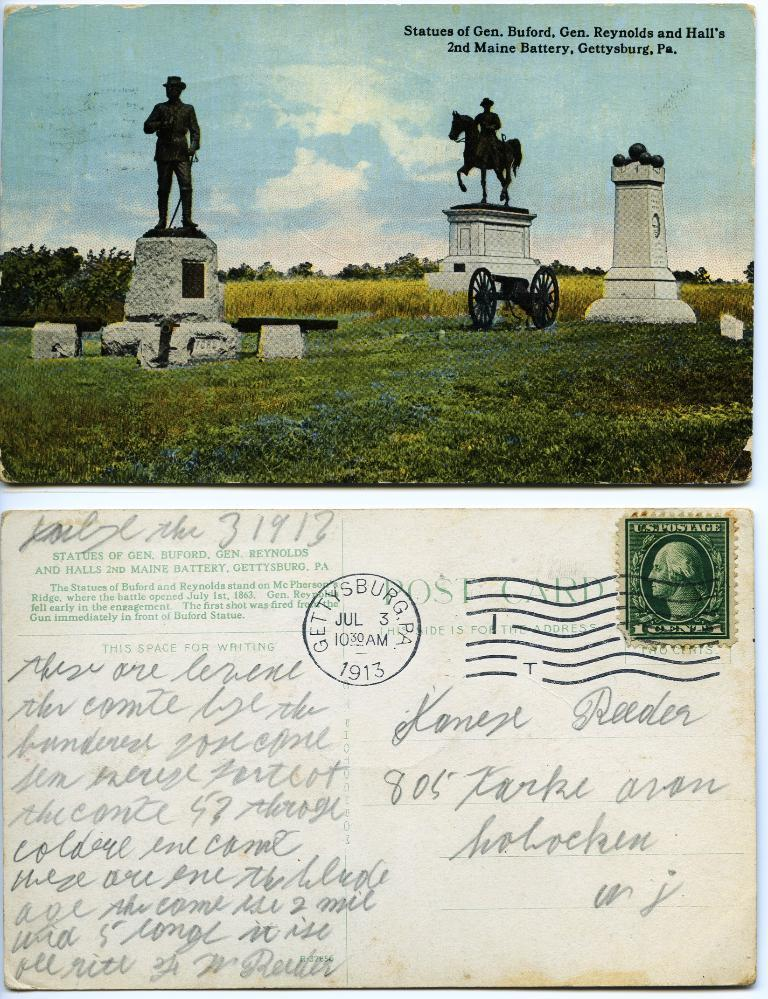What are the main subjects in the image? There are two photographs, a statue in a garden, and a postcard in the image. Can you describe the statue in the image? The statue is located in a garden, which can be seen in the top part of the image. What is present in the bottom part of the image? There is a postcard in the bottom part of the image. Is there any text on the postcard? Yes, some matter is written on the postcard. What type of motion is the minister performing in the image? There is no minister present in the image, and therefore no motion can be observed. 